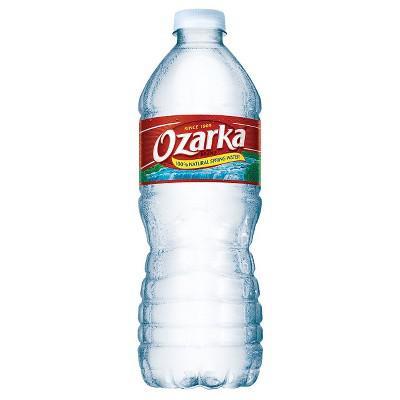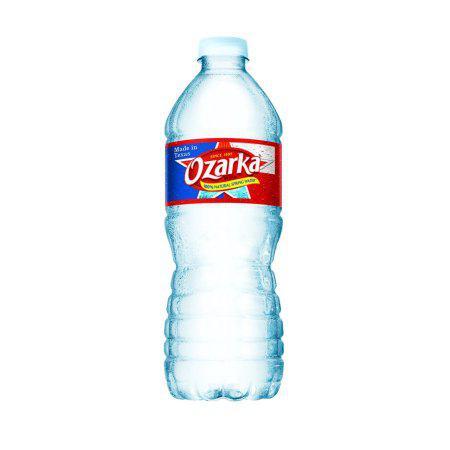The first image is the image on the left, the second image is the image on the right. Evaluate the accuracy of this statement regarding the images: "Two bottles of water are the same shape and coloring, and have white caps, but have different labels.". Is it true? Answer yes or no. Yes. 